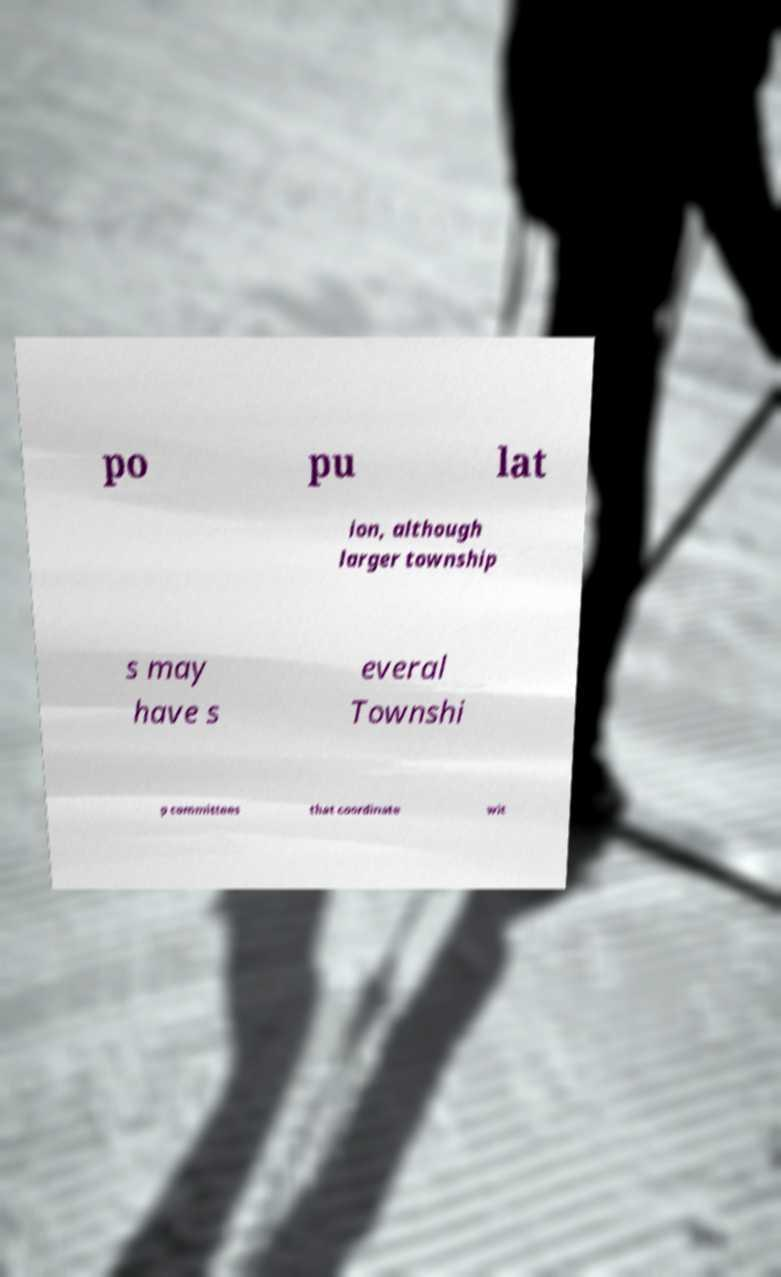What messages or text are displayed in this image? I need them in a readable, typed format. po pu lat ion, although larger township s may have s everal Townshi p committees that coordinate wit 